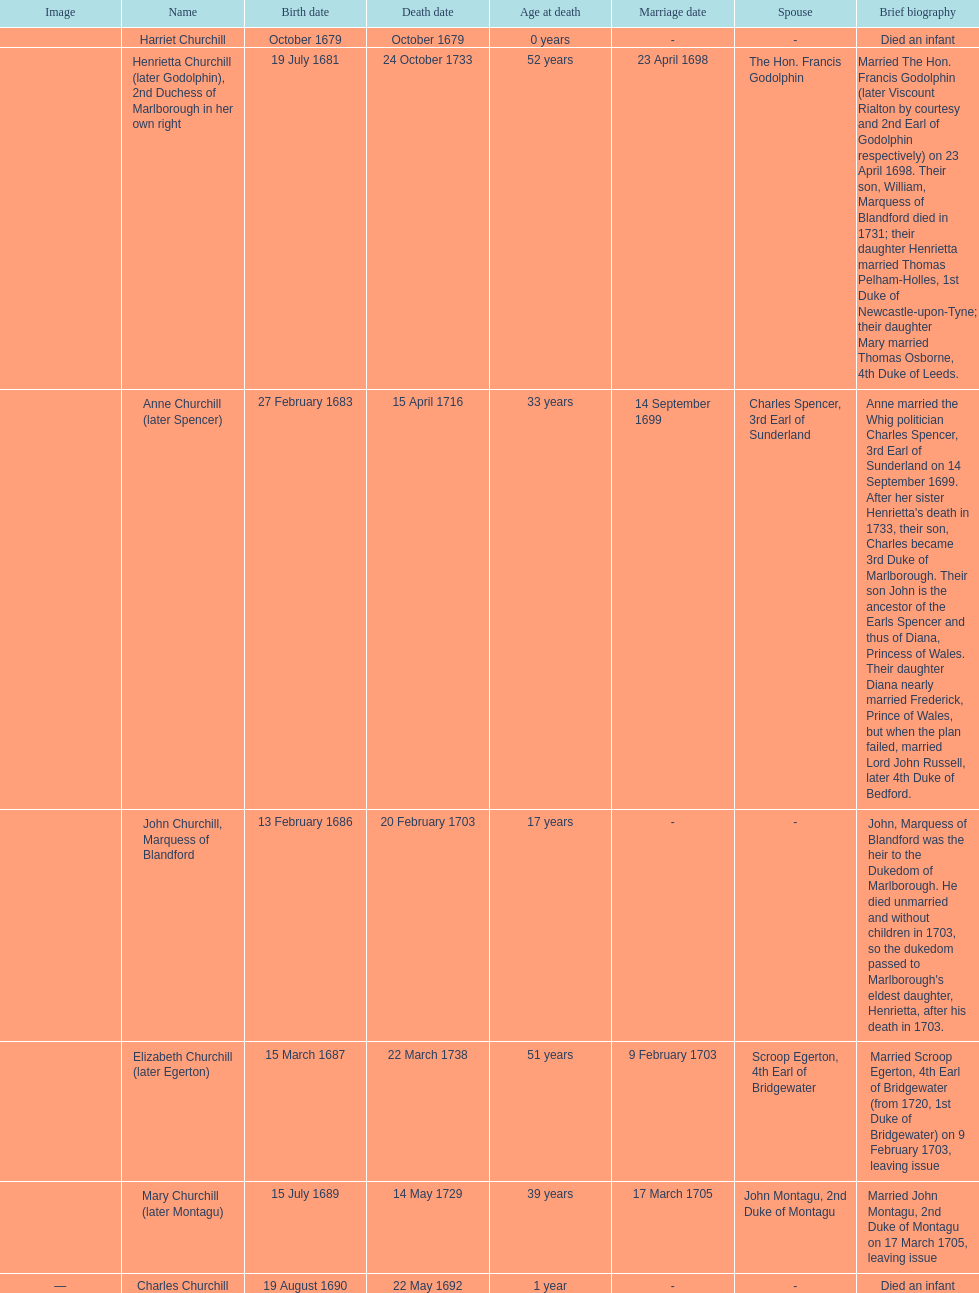Write the full table. {'header': ['Image', 'Name', 'Birth date', 'Death date', 'Age at death', 'Marriage date', 'Spouse', 'Brief biography'], 'rows': [['', 'Harriet Churchill', 'October 1679', 'October 1679', '0 years', '-', '-', 'Died an infant'], ['', 'Henrietta Churchill (later Godolphin), 2nd Duchess of Marlborough in her own right', '19 July 1681', '24 October 1733', '52 years', '23 April 1698', 'The Hon. Francis Godolphin', 'Married The Hon. Francis Godolphin (later Viscount Rialton by courtesy and 2nd Earl of Godolphin respectively) on 23 April 1698. Their son, William, Marquess of Blandford died in 1731; their daughter Henrietta married Thomas Pelham-Holles, 1st Duke of Newcastle-upon-Tyne; their daughter Mary married Thomas Osborne, 4th Duke of Leeds.'], ['', 'Anne Churchill (later Spencer)', '27 February 1683', '15 April 1716', '33 years', '14 September 1699', 'Charles Spencer, 3rd Earl of Sunderland', "Anne married the Whig politician Charles Spencer, 3rd Earl of Sunderland on 14 September 1699. After her sister Henrietta's death in 1733, their son, Charles became 3rd Duke of Marlborough. Their son John is the ancestor of the Earls Spencer and thus of Diana, Princess of Wales. Their daughter Diana nearly married Frederick, Prince of Wales, but when the plan failed, married Lord John Russell, later 4th Duke of Bedford."], ['', 'John Churchill, Marquess of Blandford', '13 February 1686', '20 February 1703', '17 years', '-', '-', "John, Marquess of Blandford was the heir to the Dukedom of Marlborough. He died unmarried and without children in 1703, so the dukedom passed to Marlborough's eldest daughter, Henrietta, after his death in 1703."], ['', 'Elizabeth Churchill (later Egerton)', '15 March 1687', '22 March 1738', '51 years', '9 February 1703', 'Scroop Egerton, 4th Earl of Bridgewater', 'Married Scroop Egerton, 4th Earl of Bridgewater (from 1720, 1st Duke of Bridgewater) on 9 February 1703, leaving issue'], ['', 'Mary Churchill (later Montagu)', '15 July 1689', '14 May 1729', '39 years', '17 March 1705', 'John Montagu, 2nd Duke of Montagu', 'Married John Montagu, 2nd Duke of Montagu on 17 March 1705, leaving issue'], ['—', 'Charles Churchill', '19 August 1690', '22 May 1692', '1 year', '-', '-', 'Died an infant']]} What was the birthdate of sarah churchill's first child? October 1679. 